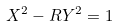<formula> <loc_0><loc_0><loc_500><loc_500>X ^ { 2 } - R Y ^ { 2 } = 1</formula> 